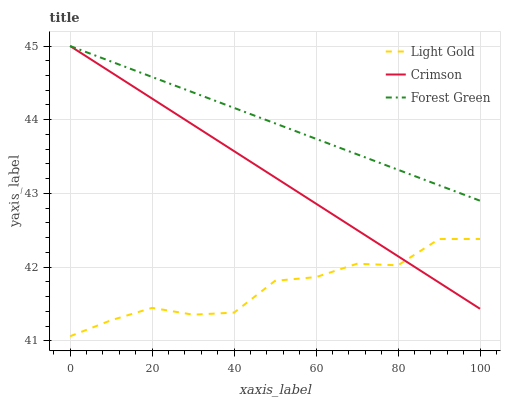Does Light Gold have the minimum area under the curve?
Answer yes or no. Yes. Does Forest Green have the maximum area under the curve?
Answer yes or no. Yes. Does Forest Green have the minimum area under the curve?
Answer yes or no. No. Does Light Gold have the maximum area under the curve?
Answer yes or no. No. Is Forest Green the smoothest?
Answer yes or no. Yes. Is Light Gold the roughest?
Answer yes or no. Yes. Is Light Gold the smoothest?
Answer yes or no. No. Is Forest Green the roughest?
Answer yes or no. No. Does Light Gold have the lowest value?
Answer yes or no. Yes. Does Forest Green have the lowest value?
Answer yes or no. No. Does Forest Green have the highest value?
Answer yes or no. Yes. Does Light Gold have the highest value?
Answer yes or no. No. Is Light Gold less than Forest Green?
Answer yes or no. Yes. Is Forest Green greater than Light Gold?
Answer yes or no. Yes. Does Crimson intersect Light Gold?
Answer yes or no. Yes. Is Crimson less than Light Gold?
Answer yes or no. No. Is Crimson greater than Light Gold?
Answer yes or no. No. Does Light Gold intersect Forest Green?
Answer yes or no. No. 